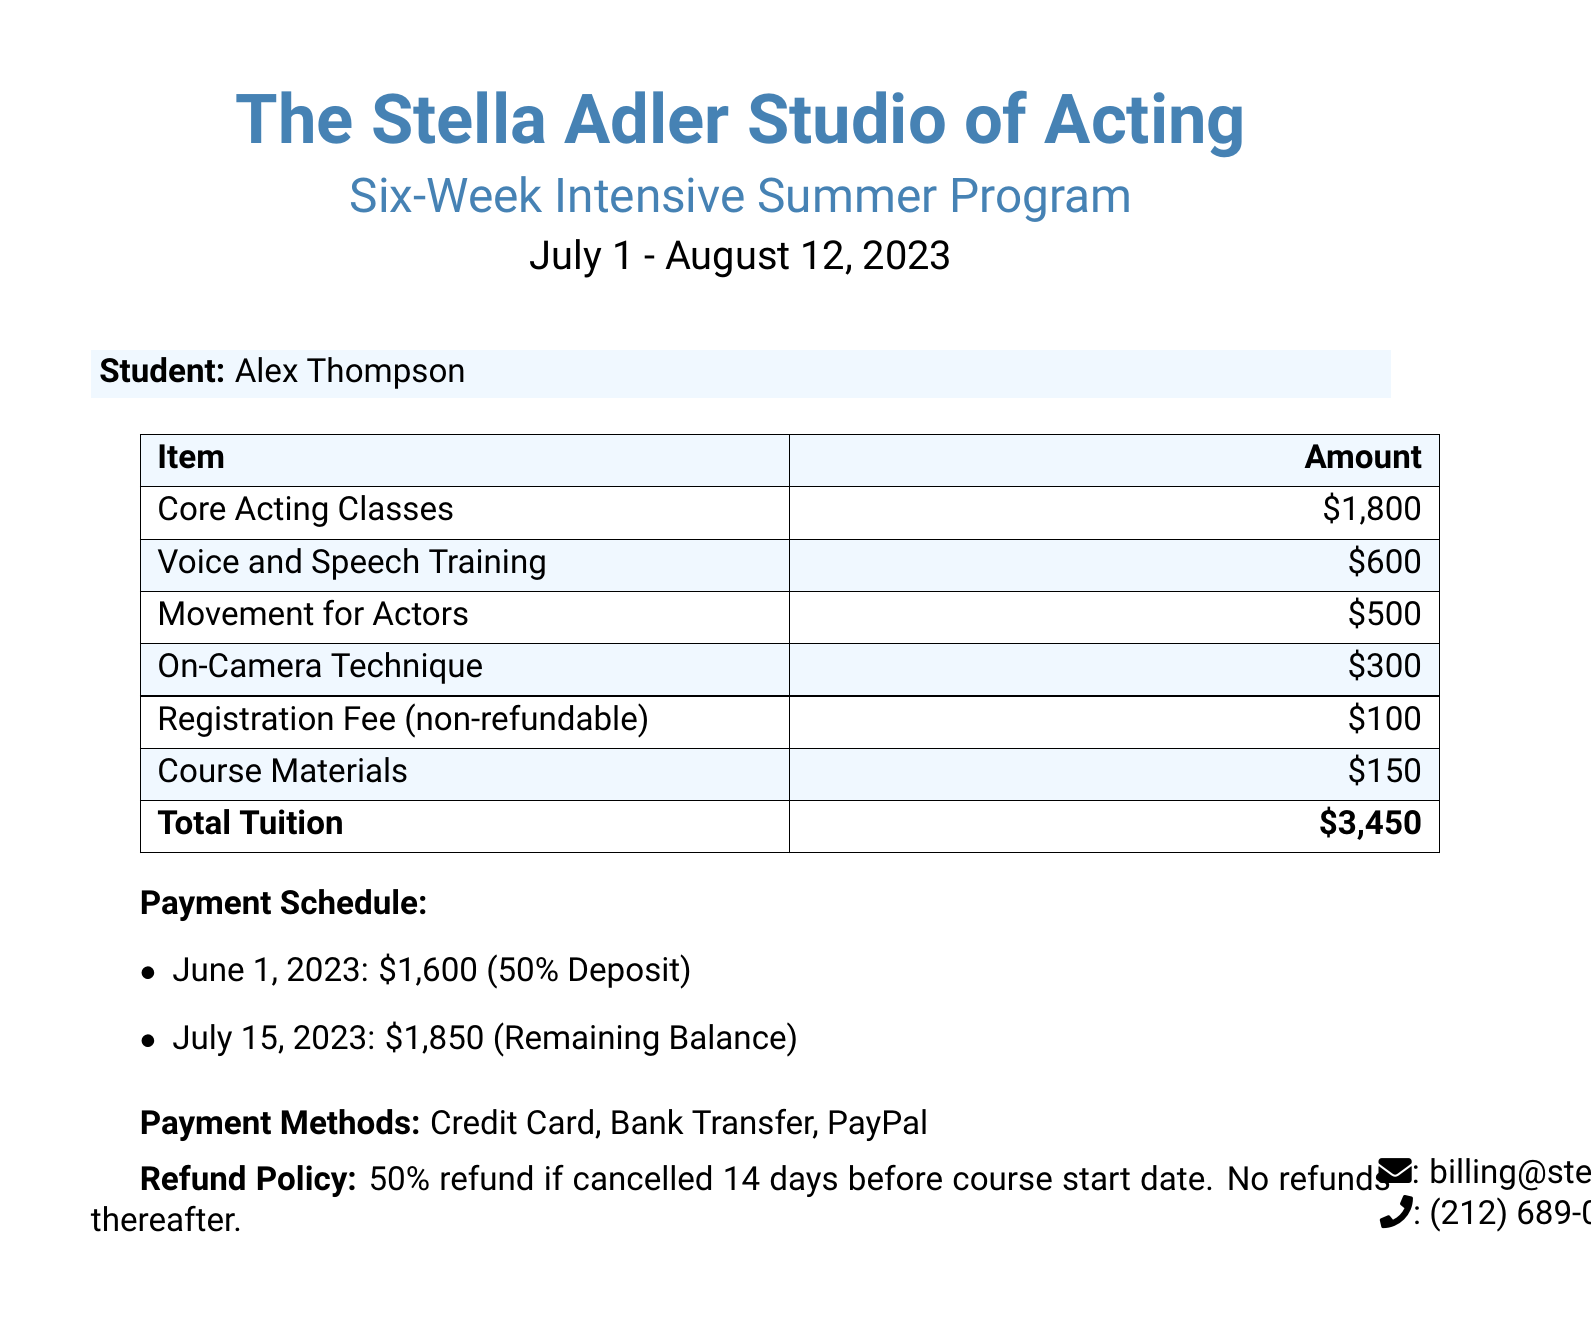What is the name of the student? The name of the student is mentioned in the document.
Answer: Alex Thompson What is the total tuition fee? The total tuition fee is calculated from all the items listed under tuition fees.
Answer: $3,450 When does the program start? The start date of the program is explicitly stated in the document.
Answer: July 1, 2023 What is the registration fee? The registration fee is a specific amount mentioned in the breakdown of fees.
Answer: $100 How much is the deposit due? The deposit amount is provided in the payment schedule.
Answer: $1,600 What is the refund policy? The refund policy details are included in the document regarding cancellation.
Answer: 50% refund if cancelled 14 days before Which payment methods are accepted? The payment methods available are listed in the document.
Answer: Credit Card, Bank Transfer, PayPal What is the last date for the remaining balance payment? The date for the remaining balance payment is specified in the payment schedule.
Answer: July 15, 2023 How many weeks is the intensive course? The duration of the intensive course is stated in the program details.
Answer: Six weeks 